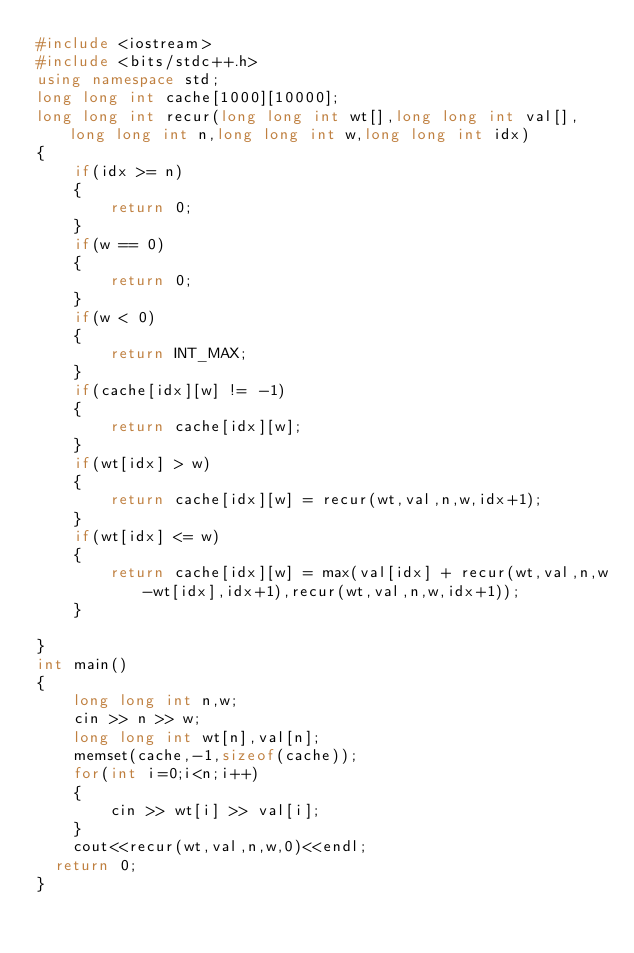Convert code to text. <code><loc_0><loc_0><loc_500><loc_500><_C++_>#include <iostream>
#include <bits/stdc++.h>
using namespace std;
long long int cache[1000][10000];
long long int recur(long long int wt[],long long int val[],long long int n,long long int w,long long int idx)
{
    if(idx >= n)
    {
        return 0;
    }
    if(w == 0)
    {
        return 0;
    }
    if(w < 0)
    {
        return INT_MAX;
    }
    if(cache[idx][w] != -1)
    {
        return cache[idx][w];
    }
    if(wt[idx] > w)
    {
        return cache[idx][w] = recur(wt,val,n,w,idx+1);
    }
    if(wt[idx] <= w)
    {
        return cache[idx][w] = max(val[idx] + recur(wt,val,n,w-wt[idx],idx+1),recur(wt,val,n,w,idx+1));
    }
    
}
int main() 
{
    long long int n,w;
    cin >> n >> w;
    long long int wt[n],val[n];
    memset(cache,-1,sizeof(cache));
    for(int i=0;i<n;i++)
    {
        cin >> wt[i] >> val[i];
    }
    cout<<recur(wt,val,n,w,0)<<endl;
	return 0;
}
</code> 